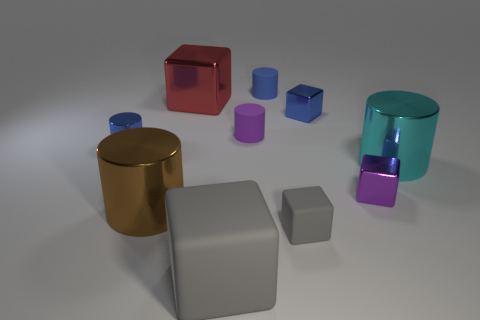What material is the small object that is the same color as the large rubber cube?
Offer a very short reply. Rubber. The rubber object that is the same color as the tiny rubber cube is what size?
Make the answer very short. Large. How many objects are either blocks that are left of the small gray cube or large cyan objects?
Your answer should be compact. 3. Does the large cyan thing have the same material as the blue block on the right side of the brown cylinder?
Your response must be concise. Yes. How many other things are the same shape as the small gray thing?
Offer a very short reply. 4. What number of things are either metal cylinders that are behind the tiny purple metallic object or small blue shiny objects on the right side of the brown metal thing?
Ensure brevity in your answer.  3. What number of other objects are there of the same color as the big rubber object?
Provide a short and direct response. 1. Are there fewer small blue things behind the blue cube than blue cylinders in front of the cyan metallic cylinder?
Provide a succinct answer. No. What number of tiny shiny cylinders are there?
Make the answer very short. 1. Are there any other things that have the same material as the tiny purple cylinder?
Your answer should be very brief. Yes. 